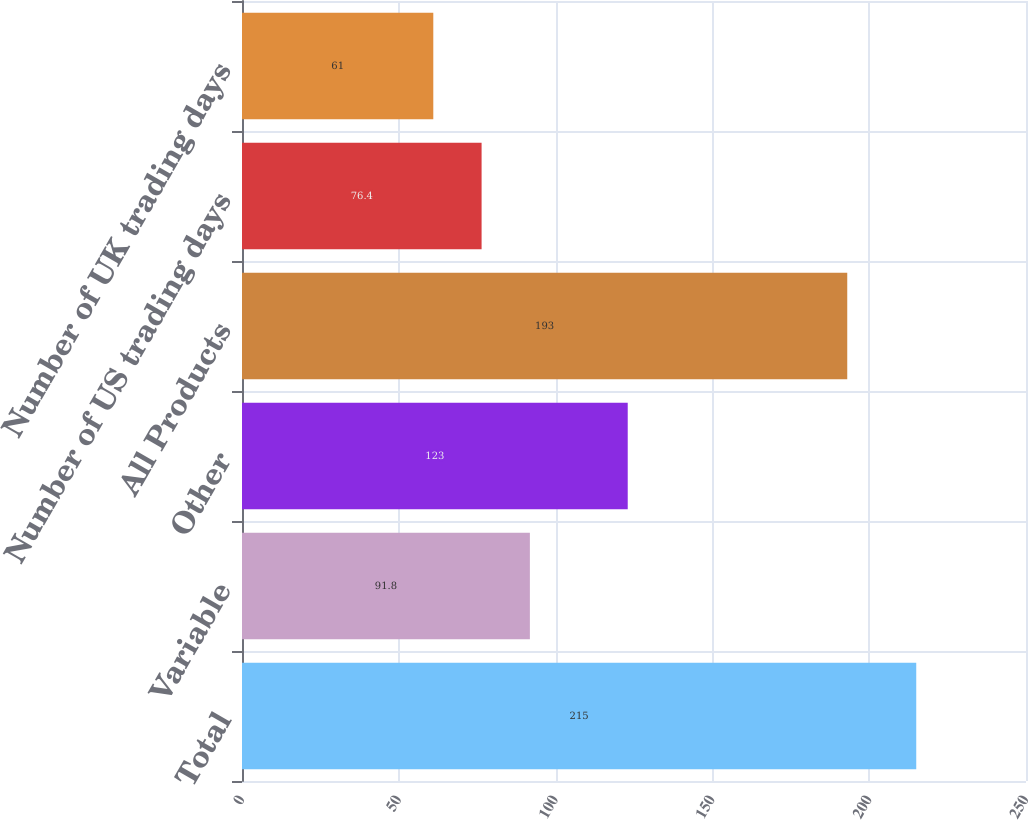Convert chart to OTSL. <chart><loc_0><loc_0><loc_500><loc_500><bar_chart><fcel>Total<fcel>Variable<fcel>Other<fcel>All Products<fcel>Number of US trading days<fcel>Number of UK trading days<nl><fcel>215<fcel>91.8<fcel>123<fcel>193<fcel>76.4<fcel>61<nl></chart> 